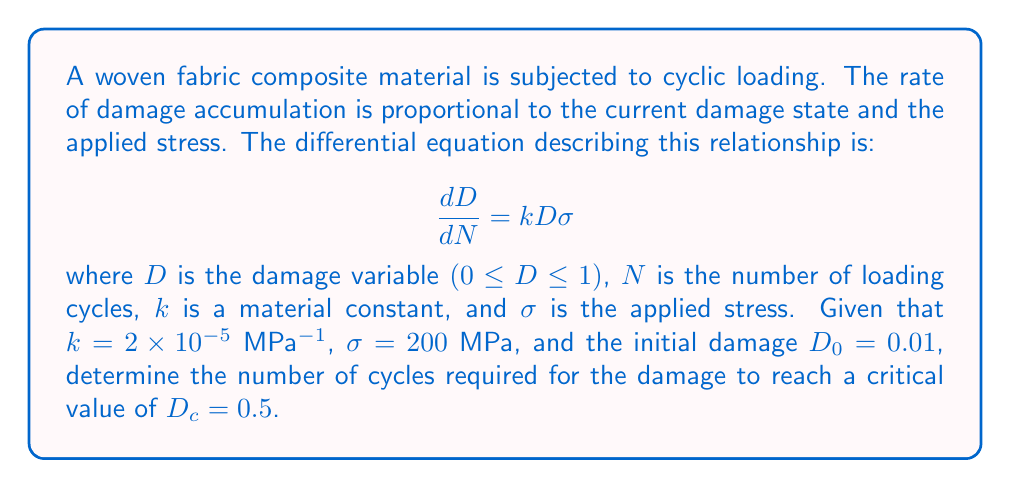Solve this math problem. To solve this problem, we need to follow these steps:

1) First, we separate the variables in the differential equation:

   $$\frac{dD}{D} = k\sigma dN$$

2) Integrate both sides:

   $$\int_{D_0}^D \frac{dD}{D} = k\sigma \int_0^N dN$$

3) Solve the integrals:

   $$[\ln D]_{D_0}^D = k\sigma N$$

4) Substitute the limits:

   $$\ln D - \ln D_0 = k\sigma N$$

5) Rearrange to solve for $N$:

   $$N = \frac{\ln D - \ln D_0}{k\sigma}$$

6) Now, we can substitute the given values:
   $k = 2 \times 10^{-5}$ MPa$^{-1}$
   $\sigma = 200$ MPa
   $D_0 = 0.01$
   $D = D_c = 0.5$

   $$N = \frac{\ln 0.5 - \ln 0.01}{(2 \times 10^{-5})(200)}$$

7) Simplify:

   $$N = \frac{\ln 50}{4 \times 10^{-3}} = \frac{3.912}{4 \times 10^{-3}} = 978,000$$

Therefore, it will take approximately 978,000 cycles for the damage to reach the critical value.
Answer: 978,000 cycles 